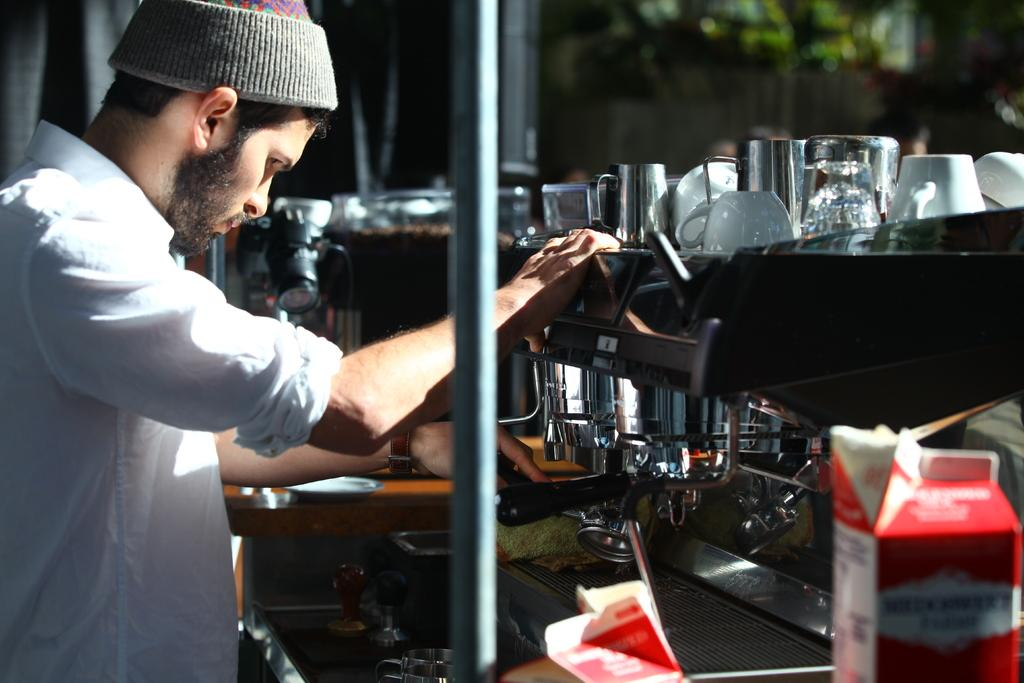Who is present on the left side of the image? There is a person on the left side of the image. What is the person interacting with in the image? The person is interacting with a coffee machine in front of them. What can be seen on the coffee machine? Glasses and cups are present on the coffee machine. What is the color of the object at the bottom of the image? There is a red color tetra pack at the bottom of the image. Can you see a snake with wings in the image? No, there is no snake or winged creature present in the image. 